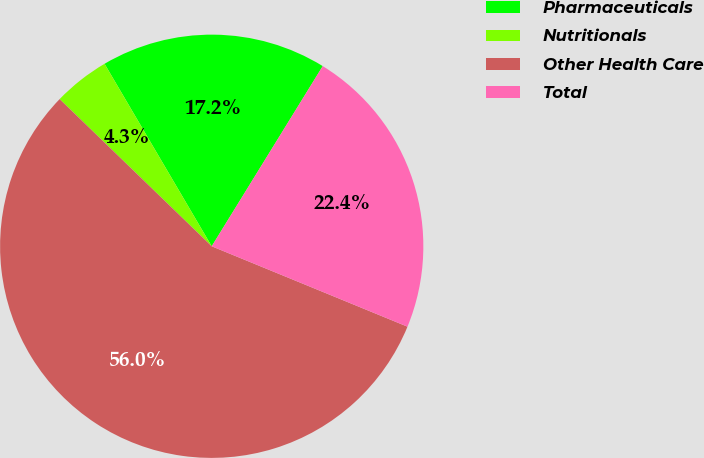Convert chart to OTSL. <chart><loc_0><loc_0><loc_500><loc_500><pie_chart><fcel>Pharmaceuticals<fcel>Nutritionals<fcel>Other Health Care<fcel>Total<nl><fcel>17.24%<fcel>4.31%<fcel>56.03%<fcel>22.41%<nl></chart> 